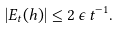<formula> <loc_0><loc_0><loc_500><loc_500>| E _ { t } ( h ) | \leq 2 \, \epsilon \, t ^ { - 1 } .</formula> 